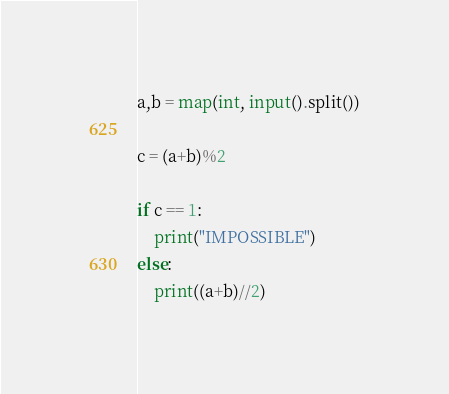Convert code to text. <code><loc_0><loc_0><loc_500><loc_500><_Python_>a,b = map(int, input().split())

c = (a+b)%2

if c == 1:
    print("IMPOSSIBLE")
else:
    print((a+b)//2)
</code> 